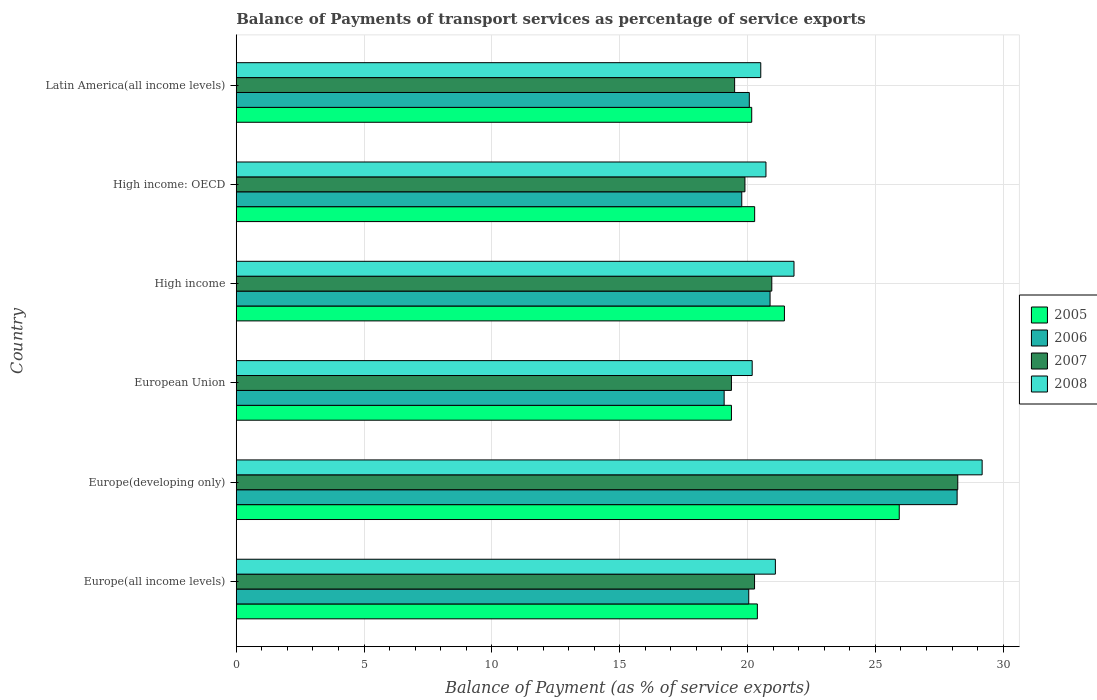How many different coloured bars are there?
Provide a succinct answer. 4. How many bars are there on the 3rd tick from the top?
Your answer should be very brief. 4. What is the label of the 5th group of bars from the top?
Keep it short and to the point. Europe(developing only). What is the balance of payments of transport services in 2006 in Latin America(all income levels)?
Your answer should be compact. 20.07. Across all countries, what is the maximum balance of payments of transport services in 2007?
Your answer should be very brief. 28.23. Across all countries, what is the minimum balance of payments of transport services in 2007?
Ensure brevity in your answer.  19.37. In which country was the balance of payments of transport services in 2007 maximum?
Offer a very short reply. Europe(developing only). What is the total balance of payments of transport services in 2005 in the graph?
Keep it short and to the point. 127.58. What is the difference between the balance of payments of transport services in 2007 in Europe(developing only) and that in High income: OECD?
Ensure brevity in your answer.  8.33. What is the difference between the balance of payments of transport services in 2006 in Europe(developing only) and the balance of payments of transport services in 2005 in Europe(all income levels)?
Your response must be concise. 7.82. What is the average balance of payments of transport services in 2007 per country?
Offer a terse response. 21.37. What is the difference between the balance of payments of transport services in 2006 and balance of payments of transport services in 2007 in Latin America(all income levels)?
Your answer should be compact. 0.57. In how many countries, is the balance of payments of transport services in 2006 greater than 21 %?
Keep it short and to the point. 1. What is the ratio of the balance of payments of transport services in 2006 in Europe(all income levels) to that in Europe(developing only)?
Make the answer very short. 0.71. What is the difference between the highest and the second highest balance of payments of transport services in 2008?
Provide a succinct answer. 7.36. What is the difference between the highest and the lowest balance of payments of transport services in 2008?
Provide a short and direct response. 9. In how many countries, is the balance of payments of transport services in 2006 greater than the average balance of payments of transport services in 2006 taken over all countries?
Keep it short and to the point. 1. Is it the case that in every country, the sum of the balance of payments of transport services in 2006 and balance of payments of transport services in 2008 is greater than the sum of balance of payments of transport services in 2007 and balance of payments of transport services in 2005?
Your response must be concise. No. What does the 2nd bar from the bottom in Europe(developing only) represents?
Offer a terse response. 2006. Is it the case that in every country, the sum of the balance of payments of transport services in 2006 and balance of payments of transport services in 2008 is greater than the balance of payments of transport services in 2005?
Make the answer very short. Yes. How many bars are there?
Give a very brief answer. 24. Are the values on the major ticks of X-axis written in scientific E-notation?
Provide a short and direct response. No. Does the graph contain any zero values?
Your answer should be very brief. No. Where does the legend appear in the graph?
Give a very brief answer. Center right. How are the legend labels stacked?
Give a very brief answer. Vertical. What is the title of the graph?
Offer a very short reply. Balance of Payments of transport services as percentage of service exports. Does "1992" appear as one of the legend labels in the graph?
Your response must be concise. No. What is the label or title of the X-axis?
Provide a short and direct response. Balance of Payment (as % of service exports). What is the label or title of the Y-axis?
Your answer should be very brief. Country. What is the Balance of Payment (as % of service exports) in 2005 in Europe(all income levels)?
Offer a terse response. 20.39. What is the Balance of Payment (as % of service exports) of 2006 in Europe(all income levels)?
Give a very brief answer. 20.05. What is the Balance of Payment (as % of service exports) in 2007 in Europe(all income levels)?
Give a very brief answer. 20.28. What is the Balance of Payment (as % of service exports) of 2008 in Europe(all income levels)?
Keep it short and to the point. 21.09. What is the Balance of Payment (as % of service exports) of 2005 in Europe(developing only)?
Your response must be concise. 25.94. What is the Balance of Payment (as % of service exports) in 2006 in Europe(developing only)?
Your answer should be compact. 28.2. What is the Balance of Payment (as % of service exports) in 2007 in Europe(developing only)?
Provide a short and direct response. 28.23. What is the Balance of Payment (as % of service exports) of 2008 in Europe(developing only)?
Provide a short and direct response. 29.18. What is the Balance of Payment (as % of service exports) in 2005 in European Union?
Keep it short and to the point. 19.37. What is the Balance of Payment (as % of service exports) of 2006 in European Union?
Keep it short and to the point. 19.09. What is the Balance of Payment (as % of service exports) of 2007 in European Union?
Your answer should be compact. 19.37. What is the Balance of Payment (as % of service exports) of 2008 in European Union?
Provide a succinct answer. 20.18. What is the Balance of Payment (as % of service exports) of 2005 in High income?
Ensure brevity in your answer.  21.44. What is the Balance of Payment (as % of service exports) of 2006 in High income?
Provide a short and direct response. 20.88. What is the Balance of Payment (as % of service exports) of 2007 in High income?
Your response must be concise. 20.95. What is the Balance of Payment (as % of service exports) in 2008 in High income?
Your answer should be very brief. 21.82. What is the Balance of Payment (as % of service exports) of 2005 in High income: OECD?
Your answer should be compact. 20.28. What is the Balance of Payment (as % of service exports) of 2006 in High income: OECD?
Offer a terse response. 19.78. What is the Balance of Payment (as % of service exports) of 2007 in High income: OECD?
Make the answer very short. 19.9. What is the Balance of Payment (as % of service exports) of 2008 in High income: OECD?
Your answer should be compact. 20.72. What is the Balance of Payment (as % of service exports) of 2005 in Latin America(all income levels)?
Keep it short and to the point. 20.17. What is the Balance of Payment (as % of service exports) in 2006 in Latin America(all income levels)?
Offer a terse response. 20.07. What is the Balance of Payment (as % of service exports) in 2007 in Latin America(all income levels)?
Make the answer very short. 19.5. What is the Balance of Payment (as % of service exports) in 2008 in Latin America(all income levels)?
Your response must be concise. 20.52. Across all countries, what is the maximum Balance of Payment (as % of service exports) of 2005?
Provide a succinct answer. 25.94. Across all countries, what is the maximum Balance of Payment (as % of service exports) in 2006?
Offer a terse response. 28.2. Across all countries, what is the maximum Balance of Payment (as % of service exports) in 2007?
Provide a short and direct response. 28.23. Across all countries, what is the maximum Balance of Payment (as % of service exports) of 2008?
Give a very brief answer. 29.18. Across all countries, what is the minimum Balance of Payment (as % of service exports) in 2005?
Provide a short and direct response. 19.37. Across all countries, what is the minimum Balance of Payment (as % of service exports) of 2006?
Keep it short and to the point. 19.09. Across all countries, what is the minimum Balance of Payment (as % of service exports) of 2007?
Your answer should be very brief. 19.37. Across all countries, what is the minimum Balance of Payment (as % of service exports) of 2008?
Ensure brevity in your answer.  20.18. What is the total Balance of Payment (as % of service exports) of 2005 in the graph?
Ensure brevity in your answer.  127.58. What is the total Balance of Payment (as % of service exports) of 2006 in the graph?
Provide a succinct answer. 128.07. What is the total Balance of Payment (as % of service exports) of 2007 in the graph?
Ensure brevity in your answer.  128.22. What is the total Balance of Payment (as % of service exports) of 2008 in the graph?
Provide a succinct answer. 133.51. What is the difference between the Balance of Payment (as % of service exports) of 2005 in Europe(all income levels) and that in Europe(developing only)?
Provide a short and direct response. -5.55. What is the difference between the Balance of Payment (as % of service exports) of 2006 in Europe(all income levels) and that in Europe(developing only)?
Your answer should be very brief. -8.15. What is the difference between the Balance of Payment (as % of service exports) in 2007 in Europe(all income levels) and that in Europe(developing only)?
Your answer should be very brief. -7.95. What is the difference between the Balance of Payment (as % of service exports) in 2008 in Europe(all income levels) and that in Europe(developing only)?
Keep it short and to the point. -8.09. What is the difference between the Balance of Payment (as % of service exports) in 2005 in Europe(all income levels) and that in European Union?
Offer a very short reply. 1.01. What is the difference between the Balance of Payment (as % of service exports) in 2006 in Europe(all income levels) and that in European Union?
Offer a very short reply. 0.96. What is the difference between the Balance of Payment (as % of service exports) in 2007 in Europe(all income levels) and that in European Union?
Provide a short and direct response. 0.9. What is the difference between the Balance of Payment (as % of service exports) in 2008 in Europe(all income levels) and that in European Union?
Make the answer very short. 0.91. What is the difference between the Balance of Payment (as % of service exports) in 2005 in Europe(all income levels) and that in High income?
Keep it short and to the point. -1.06. What is the difference between the Balance of Payment (as % of service exports) in 2006 in Europe(all income levels) and that in High income?
Keep it short and to the point. -0.83. What is the difference between the Balance of Payment (as % of service exports) of 2007 in Europe(all income levels) and that in High income?
Provide a short and direct response. -0.67. What is the difference between the Balance of Payment (as % of service exports) of 2008 in Europe(all income levels) and that in High income?
Offer a terse response. -0.73. What is the difference between the Balance of Payment (as % of service exports) in 2005 in Europe(all income levels) and that in High income: OECD?
Your answer should be very brief. 0.11. What is the difference between the Balance of Payment (as % of service exports) of 2006 in Europe(all income levels) and that in High income: OECD?
Your response must be concise. 0.27. What is the difference between the Balance of Payment (as % of service exports) in 2007 in Europe(all income levels) and that in High income: OECD?
Your answer should be very brief. 0.38. What is the difference between the Balance of Payment (as % of service exports) in 2008 in Europe(all income levels) and that in High income: OECD?
Offer a very short reply. 0.37. What is the difference between the Balance of Payment (as % of service exports) of 2005 in Europe(all income levels) and that in Latin America(all income levels)?
Give a very brief answer. 0.22. What is the difference between the Balance of Payment (as % of service exports) of 2006 in Europe(all income levels) and that in Latin America(all income levels)?
Provide a succinct answer. -0.02. What is the difference between the Balance of Payment (as % of service exports) of 2007 in Europe(all income levels) and that in Latin America(all income levels)?
Offer a very short reply. 0.78. What is the difference between the Balance of Payment (as % of service exports) in 2008 in Europe(all income levels) and that in Latin America(all income levels)?
Make the answer very short. 0.57. What is the difference between the Balance of Payment (as % of service exports) in 2005 in Europe(developing only) and that in European Union?
Ensure brevity in your answer.  6.56. What is the difference between the Balance of Payment (as % of service exports) in 2006 in Europe(developing only) and that in European Union?
Give a very brief answer. 9.11. What is the difference between the Balance of Payment (as % of service exports) in 2007 in Europe(developing only) and that in European Union?
Offer a terse response. 8.85. What is the difference between the Balance of Payment (as % of service exports) of 2008 in Europe(developing only) and that in European Union?
Make the answer very short. 9. What is the difference between the Balance of Payment (as % of service exports) of 2005 in Europe(developing only) and that in High income?
Keep it short and to the point. 4.49. What is the difference between the Balance of Payment (as % of service exports) in 2006 in Europe(developing only) and that in High income?
Your response must be concise. 7.32. What is the difference between the Balance of Payment (as % of service exports) of 2007 in Europe(developing only) and that in High income?
Make the answer very short. 7.28. What is the difference between the Balance of Payment (as % of service exports) in 2008 in Europe(developing only) and that in High income?
Make the answer very short. 7.36. What is the difference between the Balance of Payment (as % of service exports) in 2005 in Europe(developing only) and that in High income: OECD?
Offer a terse response. 5.66. What is the difference between the Balance of Payment (as % of service exports) of 2006 in Europe(developing only) and that in High income: OECD?
Your answer should be compact. 8.43. What is the difference between the Balance of Payment (as % of service exports) of 2007 in Europe(developing only) and that in High income: OECD?
Keep it short and to the point. 8.33. What is the difference between the Balance of Payment (as % of service exports) in 2008 in Europe(developing only) and that in High income: OECD?
Offer a terse response. 8.46. What is the difference between the Balance of Payment (as % of service exports) of 2005 in Europe(developing only) and that in Latin America(all income levels)?
Ensure brevity in your answer.  5.77. What is the difference between the Balance of Payment (as % of service exports) of 2006 in Europe(developing only) and that in Latin America(all income levels)?
Offer a terse response. 8.13. What is the difference between the Balance of Payment (as % of service exports) of 2007 in Europe(developing only) and that in Latin America(all income levels)?
Offer a very short reply. 8.73. What is the difference between the Balance of Payment (as % of service exports) in 2008 in Europe(developing only) and that in Latin America(all income levels)?
Make the answer very short. 8.66. What is the difference between the Balance of Payment (as % of service exports) of 2005 in European Union and that in High income?
Your answer should be very brief. -2.07. What is the difference between the Balance of Payment (as % of service exports) in 2006 in European Union and that in High income?
Provide a succinct answer. -1.8. What is the difference between the Balance of Payment (as % of service exports) in 2007 in European Union and that in High income?
Offer a terse response. -1.58. What is the difference between the Balance of Payment (as % of service exports) of 2008 in European Union and that in High income?
Offer a very short reply. -1.64. What is the difference between the Balance of Payment (as % of service exports) of 2005 in European Union and that in High income: OECD?
Your response must be concise. -0.91. What is the difference between the Balance of Payment (as % of service exports) of 2006 in European Union and that in High income: OECD?
Your response must be concise. -0.69. What is the difference between the Balance of Payment (as % of service exports) of 2007 in European Union and that in High income: OECD?
Provide a short and direct response. -0.53. What is the difference between the Balance of Payment (as % of service exports) of 2008 in European Union and that in High income: OECD?
Your response must be concise. -0.54. What is the difference between the Balance of Payment (as % of service exports) in 2005 in European Union and that in Latin America(all income levels)?
Make the answer very short. -0.79. What is the difference between the Balance of Payment (as % of service exports) of 2006 in European Union and that in Latin America(all income levels)?
Offer a terse response. -0.98. What is the difference between the Balance of Payment (as % of service exports) of 2007 in European Union and that in Latin America(all income levels)?
Make the answer very short. -0.12. What is the difference between the Balance of Payment (as % of service exports) of 2008 in European Union and that in Latin America(all income levels)?
Offer a terse response. -0.34. What is the difference between the Balance of Payment (as % of service exports) of 2005 in High income and that in High income: OECD?
Offer a terse response. 1.16. What is the difference between the Balance of Payment (as % of service exports) in 2006 in High income and that in High income: OECD?
Your response must be concise. 1.11. What is the difference between the Balance of Payment (as % of service exports) in 2007 in High income and that in High income: OECD?
Your answer should be compact. 1.05. What is the difference between the Balance of Payment (as % of service exports) in 2008 in High income and that in High income: OECD?
Your answer should be very brief. 1.1. What is the difference between the Balance of Payment (as % of service exports) of 2005 in High income and that in Latin America(all income levels)?
Your response must be concise. 1.28. What is the difference between the Balance of Payment (as % of service exports) of 2006 in High income and that in Latin America(all income levels)?
Your answer should be compact. 0.81. What is the difference between the Balance of Payment (as % of service exports) of 2007 in High income and that in Latin America(all income levels)?
Make the answer very short. 1.45. What is the difference between the Balance of Payment (as % of service exports) of 2008 in High income and that in Latin America(all income levels)?
Your answer should be compact. 1.3. What is the difference between the Balance of Payment (as % of service exports) of 2005 in High income: OECD and that in Latin America(all income levels)?
Ensure brevity in your answer.  0.11. What is the difference between the Balance of Payment (as % of service exports) of 2006 in High income: OECD and that in Latin America(all income levels)?
Make the answer very short. -0.3. What is the difference between the Balance of Payment (as % of service exports) of 2007 in High income: OECD and that in Latin America(all income levels)?
Your answer should be compact. 0.4. What is the difference between the Balance of Payment (as % of service exports) of 2008 in High income: OECD and that in Latin America(all income levels)?
Your answer should be very brief. 0.2. What is the difference between the Balance of Payment (as % of service exports) of 2005 in Europe(all income levels) and the Balance of Payment (as % of service exports) of 2006 in Europe(developing only)?
Make the answer very short. -7.82. What is the difference between the Balance of Payment (as % of service exports) of 2005 in Europe(all income levels) and the Balance of Payment (as % of service exports) of 2007 in Europe(developing only)?
Offer a very short reply. -7.84. What is the difference between the Balance of Payment (as % of service exports) in 2005 in Europe(all income levels) and the Balance of Payment (as % of service exports) in 2008 in Europe(developing only)?
Your answer should be compact. -8.79. What is the difference between the Balance of Payment (as % of service exports) in 2006 in Europe(all income levels) and the Balance of Payment (as % of service exports) in 2007 in Europe(developing only)?
Provide a succinct answer. -8.18. What is the difference between the Balance of Payment (as % of service exports) of 2006 in Europe(all income levels) and the Balance of Payment (as % of service exports) of 2008 in Europe(developing only)?
Your answer should be compact. -9.13. What is the difference between the Balance of Payment (as % of service exports) of 2007 in Europe(all income levels) and the Balance of Payment (as % of service exports) of 2008 in Europe(developing only)?
Provide a short and direct response. -8.9. What is the difference between the Balance of Payment (as % of service exports) of 2005 in Europe(all income levels) and the Balance of Payment (as % of service exports) of 2006 in European Union?
Your answer should be very brief. 1.3. What is the difference between the Balance of Payment (as % of service exports) of 2005 in Europe(all income levels) and the Balance of Payment (as % of service exports) of 2007 in European Union?
Your response must be concise. 1.01. What is the difference between the Balance of Payment (as % of service exports) in 2005 in Europe(all income levels) and the Balance of Payment (as % of service exports) in 2008 in European Union?
Keep it short and to the point. 0.2. What is the difference between the Balance of Payment (as % of service exports) of 2006 in Europe(all income levels) and the Balance of Payment (as % of service exports) of 2007 in European Union?
Offer a terse response. 0.68. What is the difference between the Balance of Payment (as % of service exports) of 2006 in Europe(all income levels) and the Balance of Payment (as % of service exports) of 2008 in European Union?
Provide a short and direct response. -0.13. What is the difference between the Balance of Payment (as % of service exports) of 2007 in Europe(all income levels) and the Balance of Payment (as % of service exports) of 2008 in European Union?
Give a very brief answer. 0.09. What is the difference between the Balance of Payment (as % of service exports) in 2005 in Europe(all income levels) and the Balance of Payment (as % of service exports) in 2006 in High income?
Make the answer very short. -0.5. What is the difference between the Balance of Payment (as % of service exports) of 2005 in Europe(all income levels) and the Balance of Payment (as % of service exports) of 2007 in High income?
Keep it short and to the point. -0.56. What is the difference between the Balance of Payment (as % of service exports) in 2005 in Europe(all income levels) and the Balance of Payment (as % of service exports) in 2008 in High income?
Provide a succinct answer. -1.43. What is the difference between the Balance of Payment (as % of service exports) in 2006 in Europe(all income levels) and the Balance of Payment (as % of service exports) in 2007 in High income?
Ensure brevity in your answer.  -0.9. What is the difference between the Balance of Payment (as % of service exports) in 2006 in Europe(all income levels) and the Balance of Payment (as % of service exports) in 2008 in High income?
Make the answer very short. -1.77. What is the difference between the Balance of Payment (as % of service exports) of 2007 in Europe(all income levels) and the Balance of Payment (as % of service exports) of 2008 in High income?
Make the answer very short. -1.54. What is the difference between the Balance of Payment (as % of service exports) of 2005 in Europe(all income levels) and the Balance of Payment (as % of service exports) of 2006 in High income: OECD?
Give a very brief answer. 0.61. What is the difference between the Balance of Payment (as % of service exports) in 2005 in Europe(all income levels) and the Balance of Payment (as % of service exports) in 2007 in High income: OECD?
Provide a short and direct response. 0.49. What is the difference between the Balance of Payment (as % of service exports) in 2005 in Europe(all income levels) and the Balance of Payment (as % of service exports) in 2008 in High income: OECD?
Keep it short and to the point. -0.34. What is the difference between the Balance of Payment (as % of service exports) in 2006 in Europe(all income levels) and the Balance of Payment (as % of service exports) in 2007 in High income: OECD?
Your response must be concise. 0.15. What is the difference between the Balance of Payment (as % of service exports) in 2006 in Europe(all income levels) and the Balance of Payment (as % of service exports) in 2008 in High income: OECD?
Your answer should be very brief. -0.67. What is the difference between the Balance of Payment (as % of service exports) of 2007 in Europe(all income levels) and the Balance of Payment (as % of service exports) of 2008 in High income: OECD?
Your answer should be compact. -0.45. What is the difference between the Balance of Payment (as % of service exports) in 2005 in Europe(all income levels) and the Balance of Payment (as % of service exports) in 2006 in Latin America(all income levels)?
Give a very brief answer. 0.31. What is the difference between the Balance of Payment (as % of service exports) of 2005 in Europe(all income levels) and the Balance of Payment (as % of service exports) of 2007 in Latin America(all income levels)?
Your answer should be compact. 0.89. What is the difference between the Balance of Payment (as % of service exports) of 2005 in Europe(all income levels) and the Balance of Payment (as % of service exports) of 2008 in Latin America(all income levels)?
Make the answer very short. -0.13. What is the difference between the Balance of Payment (as % of service exports) in 2006 in Europe(all income levels) and the Balance of Payment (as % of service exports) in 2007 in Latin America(all income levels)?
Give a very brief answer. 0.55. What is the difference between the Balance of Payment (as % of service exports) in 2006 in Europe(all income levels) and the Balance of Payment (as % of service exports) in 2008 in Latin America(all income levels)?
Ensure brevity in your answer.  -0.47. What is the difference between the Balance of Payment (as % of service exports) of 2007 in Europe(all income levels) and the Balance of Payment (as % of service exports) of 2008 in Latin America(all income levels)?
Provide a succinct answer. -0.24. What is the difference between the Balance of Payment (as % of service exports) of 2005 in Europe(developing only) and the Balance of Payment (as % of service exports) of 2006 in European Union?
Offer a very short reply. 6.85. What is the difference between the Balance of Payment (as % of service exports) of 2005 in Europe(developing only) and the Balance of Payment (as % of service exports) of 2007 in European Union?
Make the answer very short. 6.57. What is the difference between the Balance of Payment (as % of service exports) in 2005 in Europe(developing only) and the Balance of Payment (as % of service exports) in 2008 in European Union?
Your answer should be compact. 5.75. What is the difference between the Balance of Payment (as % of service exports) in 2006 in Europe(developing only) and the Balance of Payment (as % of service exports) in 2007 in European Union?
Provide a short and direct response. 8.83. What is the difference between the Balance of Payment (as % of service exports) of 2006 in Europe(developing only) and the Balance of Payment (as % of service exports) of 2008 in European Union?
Keep it short and to the point. 8.02. What is the difference between the Balance of Payment (as % of service exports) of 2007 in Europe(developing only) and the Balance of Payment (as % of service exports) of 2008 in European Union?
Offer a terse response. 8.04. What is the difference between the Balance of Payment (as % of service exports) of 2005 in Europe(developing only) and the Balance of Payment (as % of service exports) of 2006 in High income?
Offer a very short reply. 5.05. What is the difference between the Balance of Payment (as % of service exports) of 2005 in Europe(developing only) and the Balance of Payment (as % of service exports) of 2007 in High income?
Provide a succinct answer. 4.99. What is the difference between the Balance of Payment (as % of service exports) of 2005 in Europe(developing only) and the Balance of Payment (as % of service exports) of 2008 in High income?
Offer a terse response. 4.12. What is the difference between the Balance of Payment (as % of service exports) of 2006 in Europe(developing only) and the Balance of Payment (as % of service exports) of 2007 in High income?
Your response must be concise. 7.25. What is the difference between the Balance of Payment (as % of service exports) in 2006 in Europe(developing only) and the Balance of Payment (as % of service exports) in 2008 in High income?
Offer a terse response. 6.38. What is the difference between the Balance of Payment (as % of service exports) in 2007 in Europe(developing only) and the Balance of Payment (as % of service exports) in 2008 in High income?
Your answer should be very brief. 6.41. What is the difference between the Balance of Payment (as % of service exports) in 2005 in Europe(developing only) and the Balance of Payment (as % of service exports) in 2006 in High income: OECD?
Keep it short and to the point. 6.16. What is the difference between the Balance of Payment (as % of service exports) of 2005 in Europe(developing only) and the Balance of Payment (as % of service exports) of 2007 in High income: OECD?
Your answer should be very brief. 6.04. What is the difference between the Balance of Payment (as % of service exports) in 2005 in Europe(developing only) and the Balance of Payment (as % of service exports) in 2008 in High income: OECD?
Your answer should be compact. 5.21. What is the difference between the Balance of Payment (as % of service exports) in 2006 in Europe(developing only) and the Balance of Payment (as % of service exports) in 2007 in High income: OECD?
Your answer should be compact. 8.3. What is the difference between the Balance of Payment (as % of service exports) of 2006 in Europe(developing only) and the Balance of Payment (as % of service exports) of 2008 in High income: OECD?
Make the answer very short. 7.48. What is the difference between the Balance of Payment (as % of service exports) in 2007 in Europe(developing only) and the Balance of Payment (as % of service exports) in 2008 in High income: OECD?
Ensure brevity in your answer.  7.5. What is the difference between the Balance of Payment (as % of service exports) of 2005 in Europe(developing only) and the Balance of Payment (as % of service exports) of 2006 in Latin America(all income levels)?
Your answer should be compact. 5.87. What is the difference between the Balance of Payment (as % of service exports) of 2005 in Europe(developing only) and the Balance of Payment (as % of service exports) of 2007 in Latin America(all income levels)?
Give a very brief answer. 6.44. What is the difference between the Balance of Payment (as % of service exports) of 2005 in Europe(developing only) and the Balance of Payment (as % of service exports) of 2008 in Latin America(all income levels)?
Your answer should be compact. 5.42. What is the difference between the Balance of Payment (as % of service exports) of 2006 in Europe(developing only) and the Balance of Payment (as % of service exports) of 2007 in Latin America(all income levels)?
Provide a succinct answer. 8.7. What is the difference between the Balance of Payment (as % of service exports) of 2006 in Europe(developing only) and the Balance of Payment (as % of service exports) of 2008 in Latin America(all income levels)?
Your response must be concise. 7.68. What is the difference between the Balance of Payment (as % of service exports) of 2007 in Europe(developing only) and the Balance of Payment (as % of service exports) of 2008 in Latin America(all income levels)?
Your response must be concise. 7.71. What is the difference between the Balance of Payment (as % of service exports) in 2005 in European Union and the Balance of Payment (as % of service exports) in 2006 in High income?
Offer a terse response. -1.51. What is the difference between the Balance of Payment (as % of service exports) of 2005 in European Union and the Balance of Payment (as % of service exports) of 2007 in High income?
Your answer should be very brief. -1.58. What is the difference between the Balance of Payment (as % of service exports) in 2005 in European Union and the Balance of Payment (as % of service exports) in 2008 in High income?
Give a very brief answer. -2.45. What is the difference between the Balance of Payment (as % of service exports) in 2006 in European Union and the Balance of Payment (as % of service exports) in 2007 in High income?
Ensure brevity in your answer.  -1.86. What is the difference between the Balance of Payment (as % of service exports) in 2006 in European Union and the Balance of Payment (as % of service exports) in 2008 in High income?
Ensure brevity in your answer.  -2.73. What is the difference between the Balance of Payment (as % of service exports) in 2007 in European Union and the Balance of Payment (as % of service exports) in 2008 in High income?
Make the answer very short. -2.45. What is the difference between the Balance of Payment (as % of service exports) in 2005 in European Union and the Balance of Payment (as % of service exports) in 2006 in High income: OECD?
Your answer should be compact. -0.4. What is the difference between the Balance of Payment (as % of service exports) of 2005 in European Union and the Balance of Payment (as % of service exports) of 2007 in High income: OECD?
Your answer should be compact. -0.53. What is the difference between the Balance of Payment (as % of service exports) in 2005 in European Union and the Balance of Payment (as % of service exports) in 2008 in High income: OECD?
Your answer should be compact. -1.35. What is the difference between the Balance of Payment (as % of service exports) in 2006 in European Union and the Balance of Payment (as % of service exports) in 2007 in High income: OECD?
Make the answer very short. -0.81. What is the difference between the Balance of Payment (as % of service exports) of 2006 in European Union and the Balance of Payment (as % of service exports) of 2008 in High income: OECD?
Ensure brevity in your answer.  -1.64. What is the difference between the Balance of Payment (as % of service exports) in 2007 in European Union and the Balance of Payment (as % of service exports) in 2008 in High income: OECD?
Your answer should be compact. -1.35. What is the difference between the Balance of Payment (as % of service exports) of 2005 in European Union and the Balance of Payment (as % of service exports) of 2006 in Latin America(all income levels)?
Your answer should be compact. -0.7. What is the difference between the Balance of Payment (as % of service exports) of 2005 in European Union and the Balance of Payment (as % of service exports) of 2007 in Latin America(all income levels)?
Ensure brevity in your answer.  -0.12. What is the difference between the Balance of Payment (as % of service exports) in 2005 in European Union and the Balance of Payment (as % of service exports) in 2008 in Latin America(all income levels)?
Provide a short and direct response. -1.15. What is the difference between the Balance of Payment (as % of service exports) in 2006 in European Union and the Balance of Payment (as % of service exports) in 2007 in Latin America(all income levels)?
Your answer should be very brief. -0.41. What is the difference between the Balance of Payment (as % of service exports) in 2006 in European Union and the Balance of Payment (as % of service exports) in 2008 in Latin America(all income levels)?
Provide a short and direct response. -1.43. What is the difference between the Balance of Payment (as % of service exports) of 2007 in European Union and the Balance of Payment (as % of service exports) of 2008 in Latin America(all income levels)?
Provide a short and direct response. -1.15. What is the difference between the Balance of Payment (as % of service exports) of 2005 in High income and the Balance of Payment (as % of service exports) of 2006 in High income: OECD?
Offer a terse response. 1.67. What is the difference between the Balance of Payment (as % of service exports) of 2005 in High income and the Balance of Payment (as % of service exports) of 2007 in High income: OECD?
Offer a very short reply. 1.54. What is the difference between the Balance of Payment (as % of service exports) in 2005 in High income and the Balance of Payment (as % of service exports) in 2008 in High income: OECD?
Offer a very short reply. 0.72. What is the difference between the Balance of Payment (as % of service exports) of 2006 in High income and the Balance of Payment (as % of service exports) of 2008 in High income: OECD?
Offer a very short reply. 0.16. What is the difference between the Balance of Payment (as % of service exports) of 2007 in High income and the Balance of Payment (as % of service exports) of 2008 in High income: OECD?
Provide a succinct answer. 0.23. What is the difference between the Balance of Payment (as % of service exports) of 2005 in High income and the Balance of Payment (as % of service exports) of 2006 in Latin America(all income levels)?
Provide a succinct answer. 1.37. What is the difference between the Balance of Payment (as % of service exports) in 2005 in High income and the Balance of Payment (as % of service exports) in 2007 in Latin America(all income levels)?
Give a very brief answer. 1.95. What is the difference between the Balance of Payment (as % of service exports) of 2005 in High income and the Balance of Payment (as % of service exports) of 2008 in Latin America(all income levels)?
Your answer should be very brief. 0.93. What is the difference between the Balance of Payment (as % of service exports) of 2006 in High income and the Balance of Payment (as % of service exports) of 2007 in Latin America(all income levels)?
Keep it short and to the point. 1.39. What is the difference between the Balance of Payment (as % of service exports) of 2006 in High income and the Balance of Payment (as % of service exports) of 2008 in Latin America(all income levels)?
Your answer should be very brief. 0.36. What is the difference between the Balance of Payment (as % of service exports) of 2007 in High income and the Balance of Payment (as % of service exports) of 2008 in Latin America(all income levels)?
Ensure brevity in your answer.  0.43. What is the difference between the Balance of Payment (as % of service exports) in 2005 in High income: OECD and the Balance of Payment (as % of service exports) in 2006 in Latin America(all income levels)?
Make the answer very short. 0.21. What is the difference between the Balance of Payment (as % of service exports) of 2005 in High income: OECD and the Balance of Payment (as % of service exports) of 2007 in Latin America(all income levels)?
Ensure brevity in your answer.  0.78. What is the difference between the Balance of Payment (as % of service exports) of 2005 in High income: OECD and the Balance of Payment (as % of service exports) of 2008 in Latin America(all income levels)?
Offer a terse response. -0.24. What is the difference between the Balance of Payment (as % of service exports) of 2006 in High income: OECD and the Balance of Payment (as % of service exports) of 2007 in Latin America(all income levels)?
Give a very brief answer. 0.28. What is the difference between the Balance of Payment (as % of service exports) in 2006 in High income: OECD and the Balance of Payment (as % of service exports) in 2008 in Latin America(all income levels)?
Give a very brief answer. -0.74. What is the difference between the Balance of Payment (as % of service exports) of 2007 in High income: OECD and the Balance of Payment (as % of service exports) of 2008 in Latin America(all income levels)?
Provide a succinct answer. -0.62. What is the average Balance of Payment (as % of service exports) in 2005 per country?
Your answer should be compact. 21.26. What is the average Balance of Payment (as % of service exports) of 2006 per country?
Make the answer very short. 21.34. What is the average Balance of Payment (as % of service exports) of 2007 per country?
Offer a terse response. 21.37. What is the average Balance of Payment (as % of service exports) in 2008 per country?
Keep it short and to the point. 22.25. What is the difference between the Balance of Payment (as % of service exports) of 2005 and Balance of Payment (as % of service exports) of 2006 in Europe(all income levels)?
Provide a short and direct response. 0.34. What is the difference between the Balance of Payment (as % of service exports) in 2005 and Balance of Payment (as % of service exports) in 2007 in Europe(all income levels)?
Keep it short and to the point. 0.11. What is the difference between the Balance of Payment (as % of service exports) of 2005 and Balance of Payment (as % of service exports) of 2008 in Europe(all income levels)?
Your answer should be compact. -0.71. What is the difference between the Balance of Payment (as % of service exports) of 2006 and Balance of Payment (as % of service exports) of 2007 in Europe(all income levels)?
Offer a very short reply. -0.23. What is the difference between the Balance of Payment (as % of service exports) of 2006 and Balance of Payment (as % of service exports) of 2008 in Europe(all income levels)?
Give a very brief answer. -1.04. What is the difference between the Balance of Payment (as % of service exports) in 2007 and Balance of Payment (as % of service exports) in 2008 in Europe(all income levels)?
Offer a very short reply. -0.82. What is the difference between the Balance of Payment (as % of service exports) in 2005 and Balance of Payment (as % of service exports) in 2006 in Europe(developing only)?
Your answer should be compact. -2.26. What is the difference between the Balance of Payment (as % of service exports) in 2005 and Balance of Payment (as % of service exports) in 2007 in Europe(developing only)?
Your response must be concise. -2.29. What is the difference between the Balance of Payment (as % of service exports) of 2005 and Balance of Payment (as % of service exports) of 2008 in Europe(developing only)?
Give a very brief answer. -3.24. What is the difference between the Balance of Payment (as % of service exports) of 2006 and Balance of Payment (as % of service exports) of 2007 in Europe(developing only)?
Your answer should be compact. -0.02. What is the difference between the Balance of Payment (as % of service exports) in 2006 and Balance of Payment (as % of service exports) in 2008 in Europe(developing only)?
Offer a terse response. -0.98. What is the difference between the Balance of Payment (as % of service exports) of 2007 and Balance of Payment (as % of service exports) of 2008 in Europe(developing only)?
Your answer should be very brief. -0.95. What is the difference between the Balance of Payment (as % of service exports) in 2005 and Balance of Payment (as % of service exports) in 2006 in European Union?
Offer a terse response. 0.28. What is the difference between the Balance of Payment (as % of service exports) in 2005 and Balance of Payment (as % of service exports) in 2007 in European Union?
Give a very brief answer. 0. What is the difference between the Balance of Payment (as % of service exports) in 2005 and Balance of Payment (as % of service exports) in 2008 in European Union?
Your response must be concise. -0.81. What is the difference between the Balance of Payment (as % of service exports) in 2006 and Balance of Payment (as % of service exports) in 2007 in European Union?
Your response must be concise. -0.28. What is the difference between the Balance of Payment (as % of service exports) in 2006 and Balance of Payment (as % of service exports) in 2008 in European Union?
Provide a short and direct response. -1.1. What is the difference between the Balance of Payment (as % of service exports) of 2007 and Balance of Payment (as % of service exports) of 2008 in European Union?
Provide a short and direct response. -0.81. What is the difference between the Balance of Payment (as % of service exports) of 2005 and Balance of Payment (as % of service exports) of 2006 in High income?
Ensure brevity in your answer.  0.56. What is the difference between the Balance of Payment (as % of service exports) in 2005 and Balance of Payment (as % of service exports) in 2007 in High income?
Your answer should be compact. 0.49. What is the difference between the Balance of Payment (as % of service exports) of 2005 and Balance of Payment (as % of service exports) of 2008 in High income?
Provide a succinct answer. -0.37. What is the difference between the Balance of Payment (as % of service exports) of 2006 and Balance of Payment (as % of service exports) of 2007 in High income?
Provide a short and direct response. -0.07. What is the difference between the Balance of Payment (as % of service exports) of 2006 and Balance of Payment (as % of service exports) of 2008 in High income?
Provide a succinct answer. -0.94. What is the difference between the Balance of Payment (as % of service exports) in 2007 and Balance of Payment (as % of service exports) in 2008 in High income?
Make the answer very short. -0.87. What is the difference between the Balance of Payment (as % of service exports) of 2005 and Balance of Payment (as % of service exports) of 2006 in High income: OECD?
Your answer should be very brief. 0.5. What is the difference between the Balance of Payment (as % of service exports) of 2005 and Balance of Payment (as % of service exports) of 2007 in High income: OECD?
Offer a very short reply. 0.38. What is the difference between the Balance of Payment (as % of service exports) of 2005 and Balance of Payment (as % of service exports) of 2008 in High income: OECD?
Offer a terse response. -0.44. What is the difference between the Balance of Payment (as % of service exports) of 2006 and Balance of Payment (as % of service exports) of 2007 in High income: OECD?
Your answer should be very brief. -0.12. What is the difference between the Balance of Payment (as % of service exports) in 2006 and Balance of Payment (as % of service exports) in 2008 in High income: OECD?
Your answer should be very brief. -0.95. What is the difference between the Balance of Payment (as % of service exports) in 2007 and Balance of Payment (as % of service exports) in 2008 in High income: OECD?
Make the answer very short. -0.82. What is the difference between the Balance of Payment (as % of service exports) of 2005 and Balance of Payment (as % of service exports) of 2006 in Latin America(all income levels)?
Offer a very short reply. 0.09. What is the difference between the Balance of Payment (as % of service exports) in 2005 and Balance of Payment (as % of service exports) in 2007 in Latin America(all income levels)?
Offer a terse response. 0.67. What is the difference between the Balance of Payment (as % of service exports) of 2005 and Balance of Payment (as % of service exports) of 2008 in Latin America(all income levels)?
Offer a terse response. -0.35. What is the difference between the Balance of Payment (as % of service exports) in 2006 and Balance of Payment (as % of service exports) in 2007 in Latin America(all income levels)?
Provide a succinct answer. 0.57. What is the difference between the Balance of Payment (as % of service exports) of 2006 and Balance of Payment (as % of service exports) of 2008 in Latin America(all income levels)?
Provide a succinct answer. -0.45. What is the difference between the Balance of Payment (as % of service exports) of 2007 and Balance of Payment (as % of service exports) of 2008 in Latin America(all income levels)?
Your response must be concise. -1.02. What is the ratio of the Balance of Payment (as % of service exports) in 2005 in Europe(all income levels) to that in Europe(developing only)?
Your answer should be compact. 0.79. What is the ratio of the Balance of Payment (as % of service exports) of 2006 in Europe(all income levels) to that in Europe(developing only)?
Offer a terse response. 0.71. What is the ratio of the Balance of Payment (as % of service exports) in 2007 in Europe(all income levels) to that in Europe(developing only)?
Provide a succinct answer. 0.72. What is the ratio of the Balance of Payment (as % of service exports) in 2008 in Europe(all income levels) to that in Europe(developing only)?
Give a very brief answer. 0.72. What is the ratio of the Balance of Payment (as % of service exports) of 2005 in Europe(all income levels) to that in European Union?
Provide a short and direct response. 1.05. What is the ratio of the Balance of Payment (as % of service exports) of 2006 in Europe(all income levels) to that in European Union?
Your response must be concise. 1.05. What is the ratio of the Balance of Payment (as % of service exports) of 2007 in Europe(all income levels) to that in European Union?
Make the answer very short. 1.05. What is the ratio of the Balance of Payment (as % of service exports) in 2008 in Europe(all income levels) to that in European Union?
Keep it short and to the point. 1.04. What is the ratio of the Balance of Payment (as % of service exports) in 2005 in Europe(all income levels) to that in High income?
Ensure brevity in your answer.  0.95. What is the ratio of the Balance of Payment (as % of service exports) of 2006 in Europe(all income levels) to that in High income?
Your answer should be very brief. 0.96. What is the ratio of the Balance of Payment (as % of service exports) in 2007 in Europe(all income levels) to that in High income?
Your answer should be compact. 0.97. What is the ratio of the Balance of Payment (as % of service exports) of 2008 in Europe(all income levels) to that in High income?
Give a very brief answer. 0.97. What is the ratio of the Balance of Payment (as % of service exports) in 2005 in Europe(all income levels) to that in High income: OECD?
Your answer should be compact. 1.01. What is the ratio of the Balance of Payment (as % of service exports) in 2006 in Europe(all income levels) to that in High income: OECD?
Keep it short and to the point. 1.01. What is the ratio of the Balance of Payment (as % of service exports) of 2007 in Europe(all income levels) to that in High income: OECD?
Your answer should be compact. 1.02. What is the ratio of the Balance of Payment (as % of service exports) of 2008 in Europe(all income levels) to that in High income: OECD?
Keep it short and to the point. 1.02. What is the ratio of the Balance of Payment (as % of service exports) in 2005 in Europe(all income levels) to that in Latin America(all income levels)?
Your answer should be very brief. 1.01. What is the ratio of the Balance of Payment (as % of service exports) of 2008 in Europe(all income levels) to that in Latin America(all income levels)?
Provide a short and direct response. 1.03. What is the ratio of the Balance of Payment (as % of service exports) in 2005 in Europe(developing only) to that in European Union?
Ensure brevity in your answer.  1.34. What is the ratio of the Balance of Payment (as % of service exports) in 2006 in Europe(developing only) to that in European Union?
Offer a terse response. 1.48. What is the ratio of the Balance of Payment (as % of service exports) of 2007 in Europe(developing only) to that in European Union?
Provide a succinct answer. 1.46. What is the ratio of the Balance of Payment (as % of service exports) of 2008 in Europe(developing only) to that in European Union?
Offer a terse response. 1.45. What is the ratio of the Balance of Payment (as % of service exports) in 2005 in Europe(developing only) to that in High income?
Offer a terse response. 1.21. What is the ratio of the Balance of Payment (as % of service exports) of 2006 in Europe(developing only) to that in High income?
Offer a terse response. 1.35. What is the ratio of the Balance of Payment (as % of service exports) in 2007 in Europe(developing only) to that in High income?
Give a very brief answer. 1.35. What is the ratio of the Balance of Payment (as % of service exports) of 2008 in Europe(developing only) to that in High income?
Offer a very short reply. 1.34. What is the ratio of the Balance of Payment (as % of service exports) in 2005 in Europe(developing only) to that in High income: OECD?
Keep it short and to the point. 1.28. What is the ratio of the Balance of Payment (as % of service exports) in 2006 in Europe(developing only) to that in High income: OECD?
Provide a succinct answer. 1.43. What is the ratio of the Balance of Payment (as % of service exports) in 2007 in Europe(developing only) to that in High income: OECD?
Give a very brief answer. 1.42. What is the ratio of the Balance of Payment (as % of service exports) in 2008 in Europe(developing only) to that in High income: OECD?
Provide a succinct answer. 1.41. What is the ratio of the Balance of Payment (as % of service exports) of 2005 in Europe(developing only) to that in Latin America(all income levels)?
Give a very brief answer. 1.29. What is the ratio of the Balance of Payment (as % of service exports) in 2006 in Europe(developing only) to that in Latin America(all income levels)?
Provide a succinct answer. 1.41. What is the ratio of the Balance of Payment (as % of service exports) in 2007 in Europe(developing only) to that in Latin America(all income levels)?
Give a very brief answer. 1.45. What is the ratio of the Balance of Payment (as % of service exports) in 2008 in Europe(developing only) to that in Latin America(all income levels)?
Offer a very short reply. 1.42. What is the ratio of the Balance of Payment (as % of service exports) of 2005 in European Union to that in High income?
Your response must be concise. 0.9. What is the ratio of the Balance of Payment (as % of service exports) in 2006 in European Union to that in High income?
Offer a very short reply. 0.91. What is the ratio of the Balance of Payment (as % of service exports) in 2007 in European Union to that in High income?
Your response must be concise. 0.92. What is the ratio of the Balance of Payment (as % of service exports) of 2008 in European Union to that in High income?
Provide a succinct answer. 0.93. What is the ratio of the Balance of Payment (as % of service exports) of 2005 in European Union to that in High income: OECD?
Provide a short and direct response. 0.96. What is the ratio of the Balance of Payment (as % of service exports) in 2006 in European Union to that in High income: OECD?
Provide a short and direct response. 0.97. What is the ratio of the Balance of Payment (as % of service exports) in 2007 in European Union to that in High income: OECD?
Provide a short and direct response. 0.97. What is the ratio of the Balance of Payment (as % of service exports) of 2008 in European Union to that in High income: OECD?
Your response must be concise. 0.97. What is the ratio of the Balance of Payment (as % of service exports) in 2005 in European Union to that in Latin America(all income levels)?
Ensure brevity in your answer.  0.96. What is the ratio of the Balance of Payment (as % of service exports) in 2006 in European Union to that in Latin America(all income levels)?
Provide a succinct answer. 0.95. What is the ratio of the Balance of Payment (as % of service exports) in 2008 in European Union to that in Latin America(all income levels)?
Keep it short and to the point. 0.98. What is the ratio of the Balance of Payment (as % of service exports) of 2005 in High income to that in High income: OECD?
Make the answer very short. 1.06. What is the ratio of the Balance of Payment (as % of service exports) of 2006 in High income to that in High income: OECD?
Provide a short and direct response. 1.06. What is the ratio of the Balance of Payment (as % of service exports) of 2007 in High income to that in High income: OECD?
Offer a terse response. 1.05. What is the ratio of the Balance of Payment (as % of service exports) in 2008 in High income to that in High income: OECD?
Your answer should be compact. 1.05. What is the ratio of the Balance of Payment (as % of service exports) in 2005 in High income to that in Latin America(all income levels)?
Keep it short and to the point. 1.06. What is the ratio of the Balance of Payment (as % of service exports) of 2006 in High income to that in Latin America(all income levels)?
Your answer should be compact. 1.04. What is the ratio of the Balance of Payment (as % of service exports) in 2007 in High income to that in Latin America(all income levels)?
Make the answer very short. 1.07. What is the ratio of the Balance of Payment (as % of service exports) of 2008 in High income to that in Latin America(all income levels)?
Ensure brevity in your answer.  1.06. What is the ratio of the Balance of Payment (as % of service exports) of 2007 in High income: OECD to that in Latin America(all income levels)?
Provide a succinct answer. 1.02. What is the ratio of the Balance of Payment (as % of service exports) in 2008 in High income: OECD to that in Latin America(all income levels)?
Provide a succinct answer. 1.01. What is the difference between the highest and the second highest Balance of Payment (as % of service exports) in 2005?
Provide a short and direct response. 4.49. What is the difference between the highest and the second highest Balance of Payment (as % of service exports) in 2006?
Give a very brief answer. 7.32. What is the difference between the highest and the second highest Balance of Payment (as % of service exports) in 2007?
Provide a succinct answer. 7.28. What is the difference between the highest and the second highest Balance of Payment (as % of service exports) in 2008?
Your answer should be very brief. 7.36. What is the difference between the highest and the lowest Balance of Payment (as % of service exports) in 2005?
Give a very brief answer. 6.56. What is the difference between the highest and the lowest Balance of Payment (as % of service exports) in 2006?
Provide a succinct answer. 9.11. What is the difference between the highest and the lowest Balance of Payment (as % of service exports) in 2007?
Offer a terse response. 8.85. What is the difference between the highest and the lowest Balance of Payment (as % of service exports) of 2008?
Give a very brief answer. 9. 